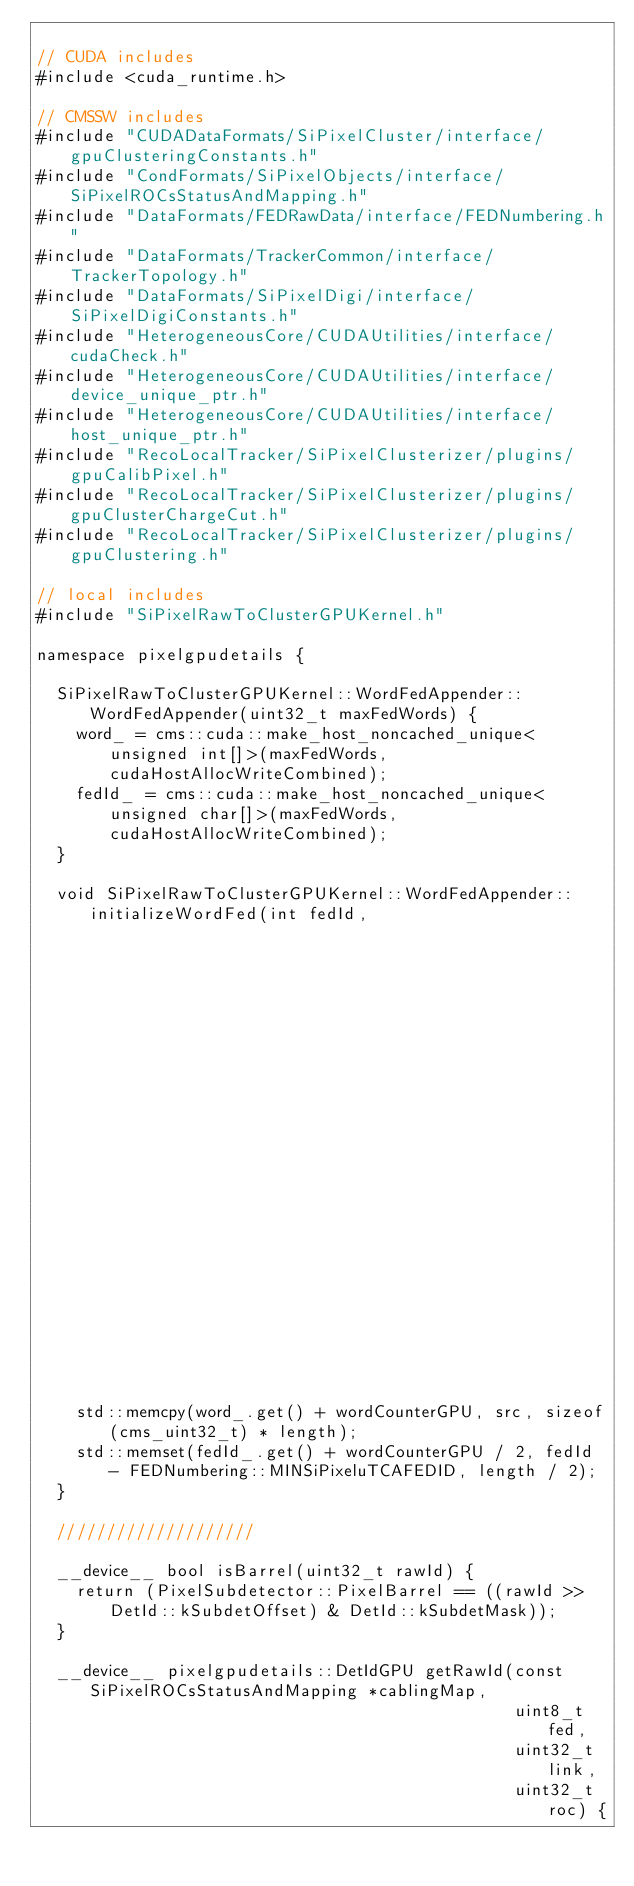Convert code to text. <code><loc_0><loc_0><loc_500><loc_500><_Cuda_>
// CUDA includes
#include <cuda_runtime.h>

// CMSSW includes
#include "CUDADataFormats/SiPixelCluster/interface/gpuClusteringConstants.h"
#include "CondFormats/SiPixelObjects/interface/SiPixelROCsStatusAndMapping.h"
#include "DataFormats/FEDRawData/interface/FEDNumbering.h"
#include "DataFormats/TrackerCommon/interface/TrackerTopology.h"
#include "DataFormats/SiPixelDigi/interface/SiPixelDigiConstants.h"
#include "HeterogeneousCore/CUDAUtilities/interface/cudaCheck.h"
#include "HeterogeneousCore/CUDAUtilities/interface/device_unique_ptr.h"
#include "HeterogeneousCore/CUDAUtilities/interface/host_unique_ptr.h"
#include "RecoLocalTracker/SiPixelClusterizer/plugins/gpuCalibPixel.h"
#include "RecoLocalTracker/SiPixelClusterizer/plugins/gpuClusterChargeCut.h"
#include "RecoLocalTracker/SiPixelClusterizer/plugins/gpuClustering.h"

// local includes
#include "SiPixelRawToClusterGPUKernel.h"

namespace pixelgpudetails {

  SiPixelRawToClusterGPUKernel::WordFedAppender::WordFedAppender(uint32_t maxFedWords) {
    word_ = cms::cuda::make_host_noncached_unique<unsigned int[]>(maxFedWords, cudaHostAllocWriteCombined);
    fedId_ = cms::cuda::make_host_noncached_unique<unsigned char[]>(maxFedWords, cudaHostAllocWriteCombined);
  }

  void SiPixelRawToClusterGPUKernel::WordFedAppender::initializeWordFed(int fedId,
                                                                        unsigned int wordCounterGPU,
                                                                        const cms_uint32_t *src,
                                                                        unsigned int length) {
    std::memcpy(word_.get() + wordCounterGPU, src, sizeof(cms_uint32_t) * length);
    std::memset(fedId_.get() + wordCounterGPU / 2, fedId - FEDNumbering::MINSiPixeluTCAFEDID, length / 2);
  }

  ////////////////////

  __device__ bool isBarrel(uint32_t rawId) {
    return (PixelSubdetector::PixelBarrel == ((rawId >> DetId::kSubdetOffset) & DetId::kSubdetMask));
  }

  __device__ pixelgpudetails::DetIdGPU getRawId(const SiPixelROCsStatusAndMapping *cablingMap,
                                                uint8_t fed,
                                                uint32_t link,
                                                uint32_t roc) {</code> 